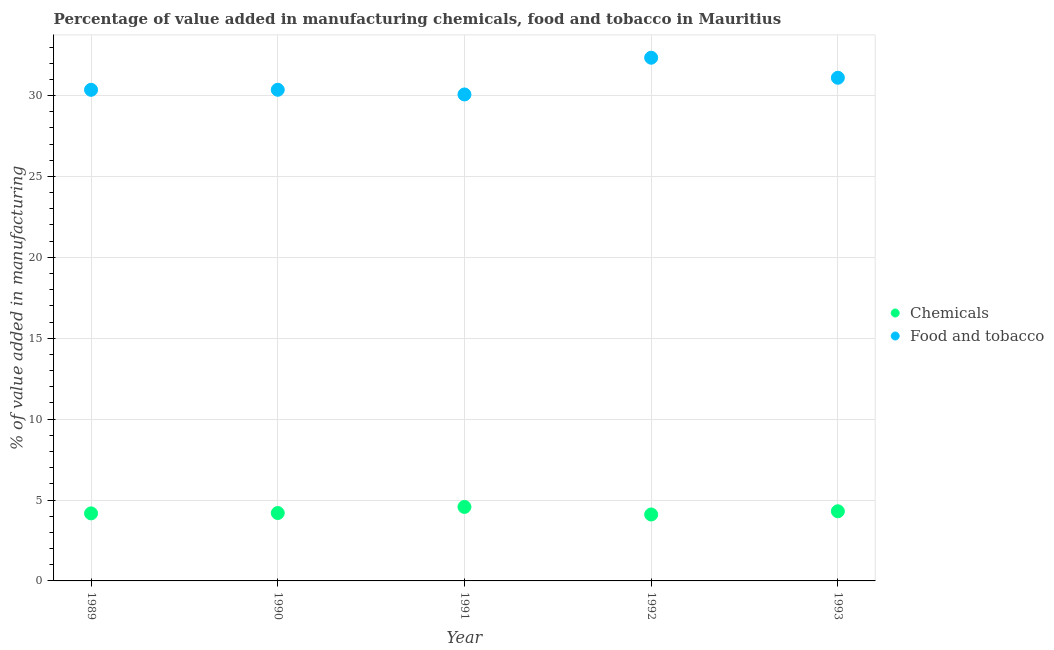How many different coloured dotlines are there?
Provide a short and direct response. 2. What is the value added by  manufacturing chemicals in 1991?
Your response must be concise. 4.57. Across all years, what is the maximum value added by  manufacturing chemicals?
Keep it short and to the point. 4.57. Across all years, what is the minimum value added by manufacturing food and tobacco?
Make the answer very short. 30.07. In which year was the value added by manufacturing food and tobacco maximum?
Your answer should be compact. 1992. What is the total value added by manufacturing food and tobacco in the graph?
Give a very brief answer. 154.23. What is the difference between the value added by manufacturing food and tobacco in 1990 and that in 1992?
Offer a very short reply. -1.98. What is the difference between the value added by manufacturing food and tobacco in 1990 and the value added by  manufacturing chemicals in 1991?
Offer a very short reply. 25.79. What is the average value added by manufacturing food and tobacco per year?
Make the answer very short. 30.85. In the year 1992, what is the difference between the value added by manufacturing food and tobacco and value added by  manufacturing chemicals?
Ensure brevity in your answer.  28.23. In how many years, is the value added by manufacturing food and tobacco greater than 6 %?
Your answer should be very brief. 5. What is the ratio of the value added by manufacturing food and tobacco in 1992 to that in 1993?
Provide a succinct answer. 1.04. Is the value added by  manufacturing chemicals in 1991 less than that in 1993?
Provide a succinct answer. No. Is the difference between the value added by manufacturing food and tobacco in 1990 and 1993 greater than the difference between the value added by  manufacturing chemicals in 1990 and 1993?
Offer a terse response. No. What is the difference between the highest and the second highest value added by  manufacturing chemicals?
Make the answer very short. 0.27. What is the difference between the highest and the lowest value added by  manufacturing chemicals?
Offer a very short reply. 0.47. In how many years, is the value added by  manufacturing chemicals greater than the average value added by  manufacturing chemicals taken over all years?
Keep it short and to the point. 2. Is the sum of the value added by manufacturing food and tobacco in 1990 and 1993 greater than the maximum value added by  manufacturing chemicals across all years?
Offer a terse response. Yes. Is the value added by  manufacturing chemicals strictly greater than the value added by manufacturing food and tobacco over the years?
Provide a succinct answer. No. Is the value added by  manufacturing chemicals strictly less than the value added by manufacturing food and tobacco over the years?
Provide a succinct answer. Yes. How many dotlines are there?
Provide a succinct answer. 2. Does the graph contain any zero values?
Ensure brevity in your answer.  No. Does the graph contain grids?
Give a very brief answer. Yes. What is the title of the graph?
Provide a succinct answer. Percentage of value added in manufacturing chemicals, food and tobacco in Mauritius. What is the label or title of the X-axis?
Offer a terse response. Year. What is the label or title of the Y-axis?
Your response must be concise. % of value added in manufacturing. What is the % of value added in manufacturing in Chemicals in 1989?
Your answer should be compact. 4.17. What is the % of value added in manufacturing of Food and tobacco in 1989?
Provide a succinct answer. 30.36. What is the % of value added in manufacturing of Chemicals in 1990?
Your answer should be very brief. 4.2. What is the % of value added in manufacturing of Food and tobacco in 1990?
Your answer should be very brief. 30.36. What is the % of value added in manufacturing of Chemicals in 1991?
Your answer should be compact. 4.57. What is the % of value added in manufacturing of Food and tobacco in 1991?
Provide a succinct answer. 30.07. What is the % of value added in manufacturing of Chemicals in 1992?
Give a very brief answer. 4.11. What is the % of value added in manufacturing in Food and tobacco in 1992?
Your answer should be compact. 32.34. What is the % of value added in manufacturing of Chemicals in 1993?
Your answer should be very brief. 4.31. What is the % of value added in manufacturing in Food and tobacco in 1993?
Ensure brevity in your answer.  31.1. Across all years, what is the maximum % of value added in manufacturing in Chemicals?
Ensure brevity in your answer.  4.57. Across all years, what is the maximum % of value added in manufacturing of Food and tobacco?
Give a very brief answer. 32.34. Across all years, what is the minimum % of value added in manufacturing of Chemicals?
Give a very brief answer. 4.11. Across all years, what is the minimum % of value added in manufacturing in Food and tobacco?
Offer a very short reply. 30.07. What is the total % of value added in manufacturing of Chemicals in the graph?
Your answer should be very brief. 21.36. What is the total % of value added in manufacturing in Food and tobacco in the graph?
Provide a succinct answer. 154.23. What is the difference between the % of value added in manufacturing of Chemicals in 1989 and that in 1990?
Provide a succinct answer. -0.02. What is the difference between the % of value added in manufacturing in Food and tobacco in 1989 and that in 1990?
Offer a terse response. -0. What is the difference between the % of value added in manufacturing in Chemicals in 1989 and that in 1991?
Keep it short and to the point. -0.4. What is the difference between the % of value added in manufacturing of Food and tobacco in 1989 and that in 1991?
Your answer should be compact. 0.29. What is the difference between the % of value added in manufacturing of Chemicals in 1989 and that in 1992?
Your answer should be compact. 0.07. What is the difference between the % of value added in manufacturing in Food and tobacco in 1989 and that in 1992?
Your response must be concise. -1.98. What is the difference between the % of value added in manufacturing of Chemicals in 1989 and that in 1993?
Offer a terse response. -0.13. What is the difference between the % of value added in manufacturing of Food and tobacco in 1989 and that in 1993?
Your response must be concise. -0.74. What is the difference between the % of value added in manufacturing in Chemicals in 1990 and that in 1991?
Offer a very short reply. -0.38. What is the difference between the % of value added in manufacturing in Food and tobacco in 1990 and that in 1991?
Your response must be concise. 0.29. What is the difference between the % of value added in manufacturing of Chemicals in 1990 and that in 1992?
Ensure brevity in your answer.  0.09. What is the difference between the % of value added in manufacturing of Food and tobacco in 1990 and that in 1992?
Offer a very short reply. -1.98. What is the difference between the % of value added in manufacturing of Chemicals in 1990 and that in 1993?
Offer a terse response. -0.11. What is the difference between the % of value added in manufacturing in Food and tobacco in 1990 and that in 1993?
Your answer should be very brief. -0.74. What is the difference between the % of value added in manufacturing in Chemicals in 1991 and that in 1992?
Provide a succinct answer. 0.47. What is the difference between the % of value added in manufacturing of Food and tobacco in 1991 and that in 1992?
Keep it short and to the point. -2.27. What is the difference between the % of value added in manufacturing in Chemicals in 1991 and that in 1993?
Give a very brief answer. 0.27. What is the difference between the % of value added in manufacturing in Food and tobacco in 1991 and that in 1993?
Offer a very short reply. -1.03. What is the difference between the % of value added in manufacturing of Chemicals in 1992 and that in 1993?
Ensure brevity in your answer.  -0.2. What is the difference between the % of value added in manufacturing in Food and tobacco in 1992 and that in 1993?
Provide a short and direct response. 1.24. What is the difference between the % of value added in manufacturing in Chemicals in 1989 and the % of value added in manufacturing in Food and tobacco in 1990?
Make the answer very short. -26.18. What is the difference between the % of value added in manufacturing in Chemicals in 1989 and the % of value added in manufacturing in Food and tobacco in 1991?
Give a very brief answer. -25.89. What is the difference between the % of value added in manufacturing of Chemicals in 1989 and the % of value added in manufacturing of Food and tobacco in 1992?
Provide a short and direct response. -28.17. What is the difference between the % of value added in manufacturing of Chemicals in 1989 and the % of value added in manufacturing of Food and tobacco in 1993?
Your answer should be compact. -26.93. What is the difference between the % of value added in manufacturing of Chemicals in 1990 and the % of value added in manufacturing of Food and tobacco in 1991?
Offer a terse response. -25.87. What is the difference between the % of value added in manufacturing in Chemicals in 1990 and the % of value added in manufacturing in Food and tobacco in 1992?
Your answer should be compact. -28.14. What is the difference between the % of value added in manufacturing of Chemicals in 1990 and the % of value added in manufacturing of Food and tobacco in 1993?
Provide a short and direct response. -26.9. What is the difference between the % of value added in manufacturing in Chemicals in 1991 and the % of value added in manufacturing in Food and tobacco in 1992?
Provide a short and direct response. -27.77. What is the difference between the % of value added in manufacturing in Chemicals in 1991 and the % of value added in manufacturing in Food and tobacco in 1993?
Offer a very short reply. -26.53. What is the difference between the % of value added in manufacturing in Chemicals in 1992 and the % of value added in manufacturing in Food and tobacco in 1993?
Ensure brevity in your answer.  -27. What is the average % of value added in manufacturing in Chemicals per year?
Keep it short and to the point. 4.27. What is the average % of value added in manufacturing of Food and tobacco per year?
Make the answer very short. 30.85. In the year 1989, what is the difference between the % of value added in manufacturing of Chemicals and % of value added in manufacturing of Food and tobacco?
Provide a succinct answer. -26.18. In the year 1990, what is the difference between the % of value added in manufacturing of Chemicals and % of value added in manufacturing of Food and tobacco?
Your answer should be very brief. -26.16. In the year 1991, what is the difference between the % of value added in manufacturing in Chemicals and % of value added in manufacturing in Food and tobacco?
Provide a succinct answer. -25.5. In the year 1992, what is the difference between the % of value added in manufacturing of Chemicals and % of value added in manufacturing of Food and tobacco?
Your answer should be very brief. -28.23. In the year 1993, what is the difference between the % of value added in manufacturing in Chemicals and % of value added in manufacturing in Food and tobacco?
Your answer should be compact. -26.8. What is the ratio of the % of value added in manufacturing of Food and tobacco in 1989 to that in 1990?
Make the answer very short. 1. What is the ratio of the % of value added in manufacturing of Chemicals in 1989 to that in 1991?
Your answer should be compact. 0.91. What is the ratio of the % of value added in manufacturing of Food and tobacco in 1989 to that in 1991?
Make the answer very short. 1.01. What is the ratio of the % of value added in manufacturing of Chemicals in 1989 to that in 1992?
Your response must be concise. 1.02. What is the ratio of the % of value added in manufacturing of Food and tobacco in 1989 to that in 1992?
Keep it short and to the point. 0.94. What is the ratio of the % of value added in manufacturing in Chemicals in 1989 to that in 1993?
Offer a terse response. 0.97. What is the ratio of the % of value added in manufacturing of Food and tobacco in 1989 to that in 1993?
Ensure brevity in your answer.  0.98. What is the ratio of the % of value added in manufacturing in Chemicals in 1990 to that in 1991?
Make the answer very short. 0.92. What is the ratio of the % of value added in manufacturing in Food and tobacco in 1990 to that in 1991?
Provide a succinct answer. 1.01. What is the ratio of the % of value added in manufacturing in Chemicals in 1990 to that in 1992?
Keep it short and to the point. 1.02. What is the ratio of the % of value added in manufacturing of Food and tobacco in 1990 to that in 1992?
Make the answer very short. 0.94. What is the ratio of the % of value added in manufacturing in Chemicals in 1990 to that in 1993?
Make the answer very short. 0.97. What is the ratio of the % of value added in manufacturing of Food and tobacco in 1990 to that in 1993?
Provide a succinct answer. 0.98. What is the ratio of the % of value added in manufacturing in Chemicals in 1991 to that in 1992?
Provide a succinct answer. 1.11. What is the ratio of the % of value added in manufacturing of Food and tobacco in 1991 to that in 1992?
Provide a short and direct response. 0.93. What is the ratio of the % of value added in manufacturing in Chemicals in 1991 to that in 1993?
Provide a short and direct response. 1.06. What is the ratio of the % of value added in manufacturing of Food and tobacco in 1991 to that in 1993?
Give a very brief answer. 0.97. What is the ratio of the % of value added in manufacturing in Chemicals in 1992 to that in 1993?
Provide a succinct answer. 0.95. What is the ratio of the % of value added in manufacturing of Food and tobacco in 1992 to that in 1993?
Offer a terse response. 1.04. What is the difference between the highest and the second highest % of value added in manufacturing in Chemicals?
Your answer should be very brief. 0.27. What is the difference between the highest and the second highest % of value added in manufacturing in Food and tobacco?
Your response must be concise. 1.24. What is the difference between the highest and the lowest % of value added in manufacturing in Chemicals?
Offer a very short reply. 0.47. What is the difference between the highest and the lowest % of value added in manufacturing of Food and tobacco?
Provide a short and direct response. 2.27. 